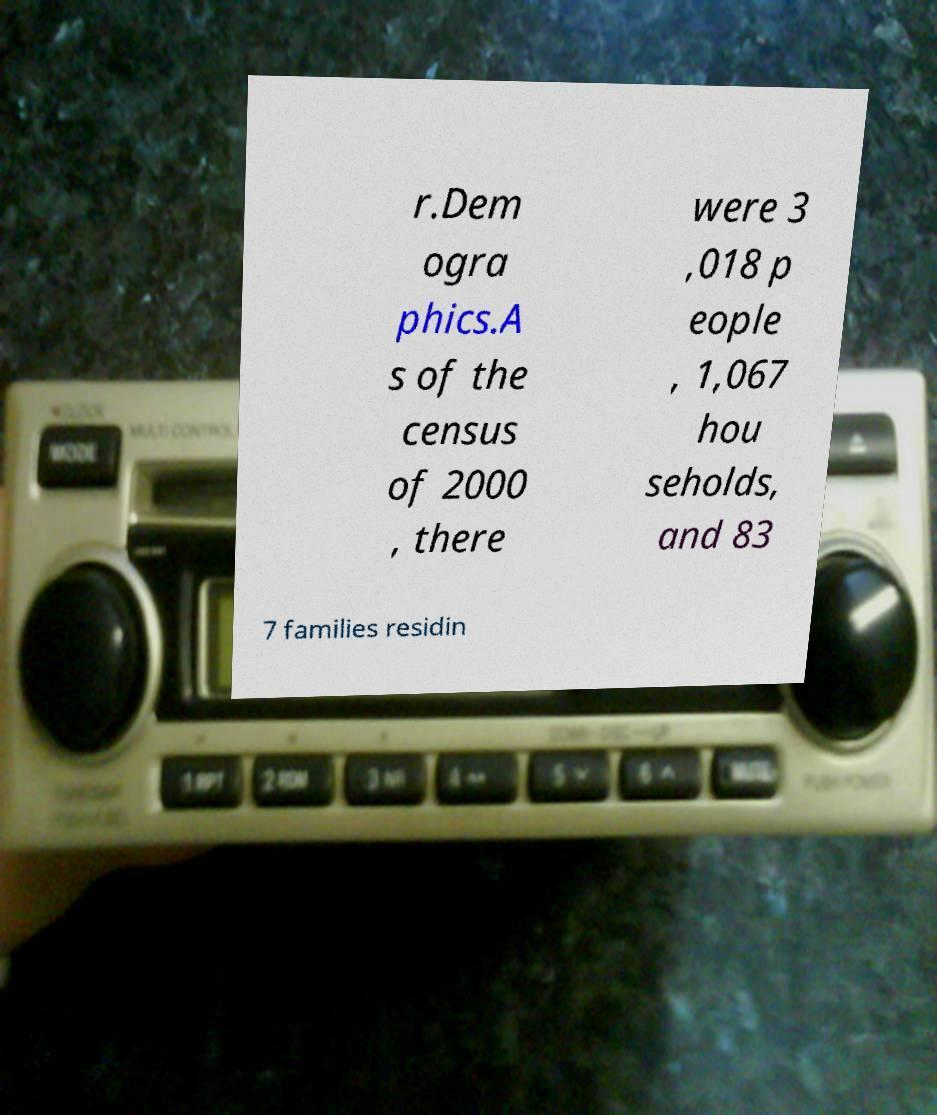What messages or text are displayed in this image? I need them in a readable, typed format. r.Dem ogra phics.A s of the census of 2000 , there were 3 ,018 p eople , 1,067 hou seholds, and 83 7 families residin 